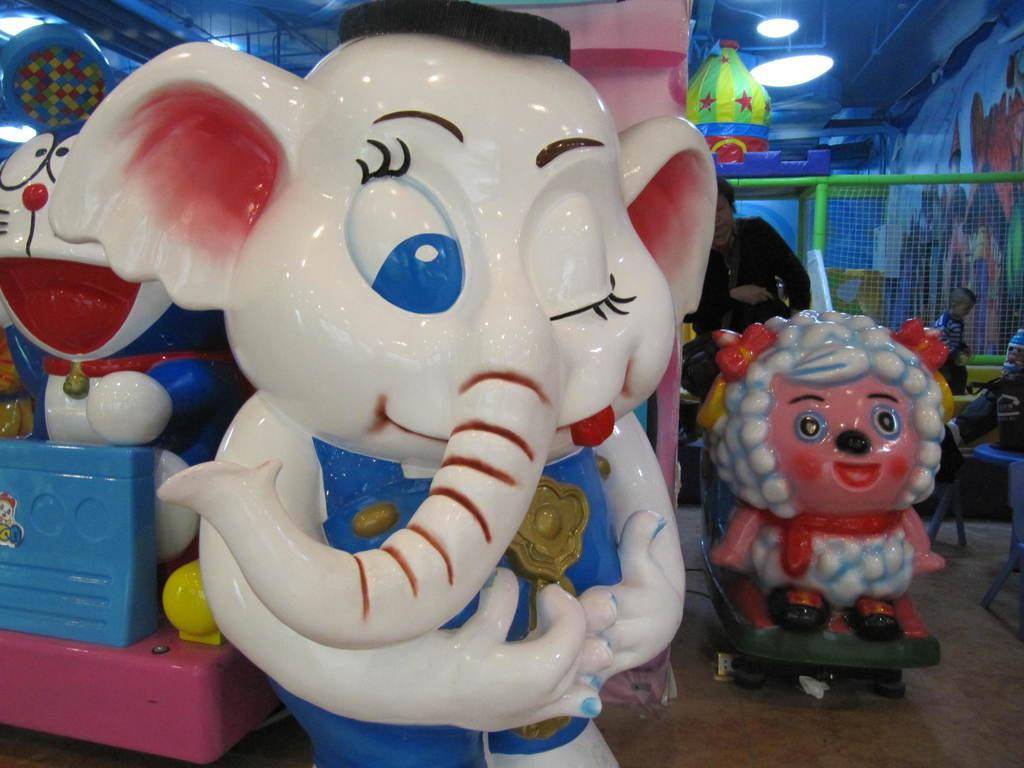What objects can be seen in the image? There are toys in the image. Can you describe the setting of the image? There is a person in the background of the image. What is the purpose of the net in the image? The net is likely used for playing or catching objects. What can be seen at the top of the image? There are lights visible at the top of the image. What type of coast is visible in the image? There is no coast visible in the image. What is being served for dinner in the image? There is no dinner being served in the image. 